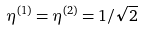Convert formula to latex. <formula><loc_0><loc_0><loc_500><loc_500>\eta ^ { ( 1 ) } = \eta ^ { ( 2 ) } = 1 / \sqrt { 2 }</formula> 